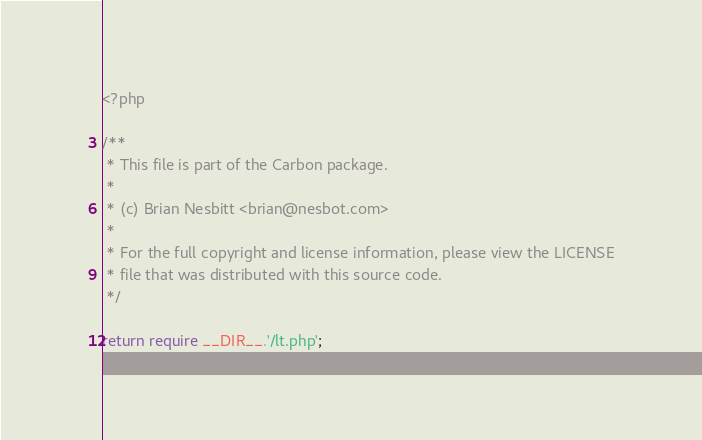Convert code to text. <code><loc_0><loc_0><loc_500><loc_500><_PHP_><?php

/**
 * This file is part of the Carbon package.
 *
 * (c) Brian Nesbitt <brian@nesbot.com>
 *
 * For the full copyright and license information, please view the LICENSE
 * file that was distributed with this source code.
 */

return require __DIR__.'/lt.php';
</code> 